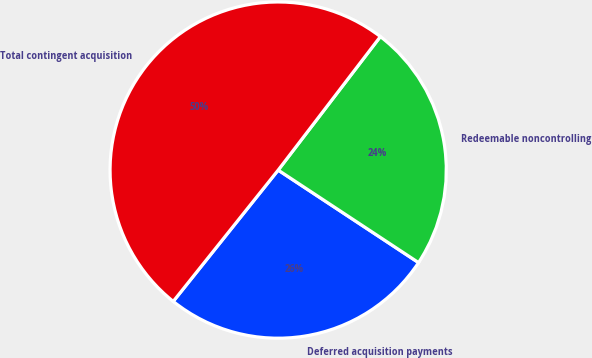Convert chart to OTSL. <chart><loc_0><loc_0><loc_500><loc_500><pie_chart><fcel>Deferred acquisition payments<fcel>Redeemable noncontrolling<fcel>Total contingent acquisition<nl><fcel>26.46%<fcel>23.88%<fcel>49.67%<nl></chart> 